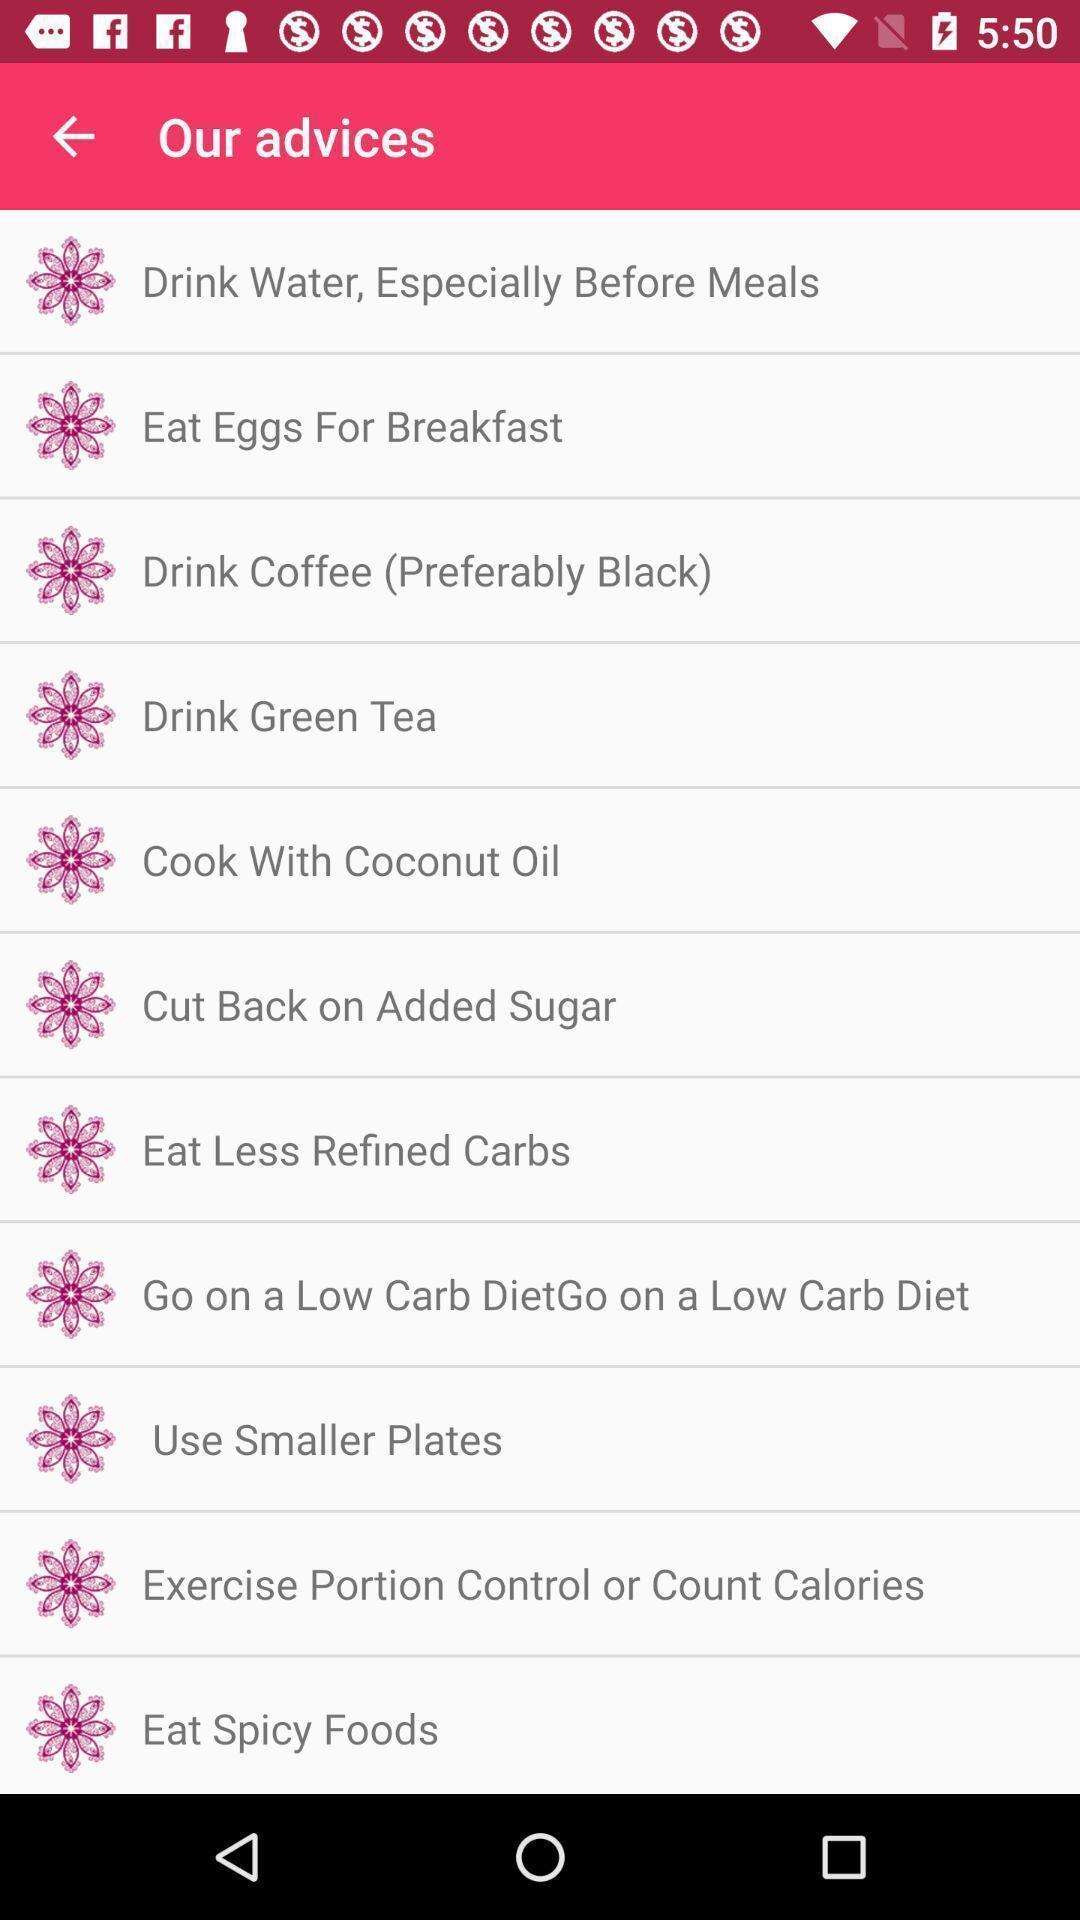Give me a narrative description of this picture. Screen showing our advices. 